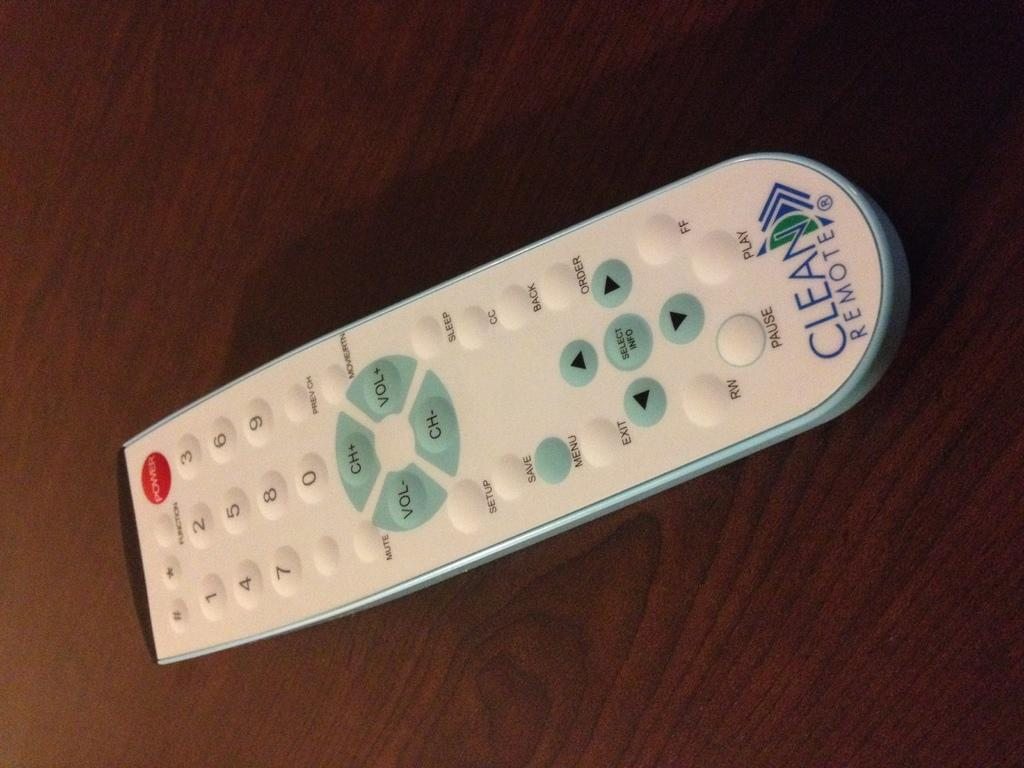Provide a one-sentence caption for the provided image. A white remote that says Clean Remote on the bottom of it. 